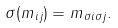<formula> <loc_0><loc_0><loc_500><loc_500>\sigma ( m _ { i j } ) = m _ { \sigma i \sigma j } .</formula> 